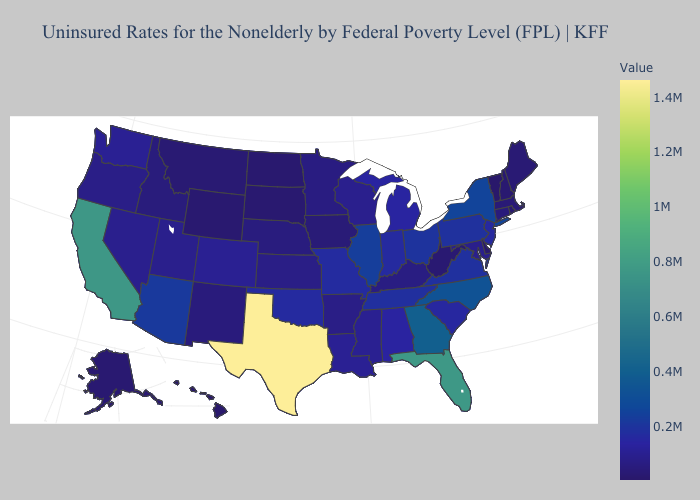Does Louisiana have the lowest value in the USA?
Keep it brief. No. Among the states that border Kentucky , does West Virginia have the lowest value?
Answer briefly. Yes. Which states hav the highest value in the MidWest?
Give a very brief answer. Illinois. Does Illinois have the highest value in the MidWest?
Give a very brief answer. Yes. Does the map have missing data?
Short answer required. No. Does Vermont have the lowest value in the USA?
Write a very short answer. Yes. 